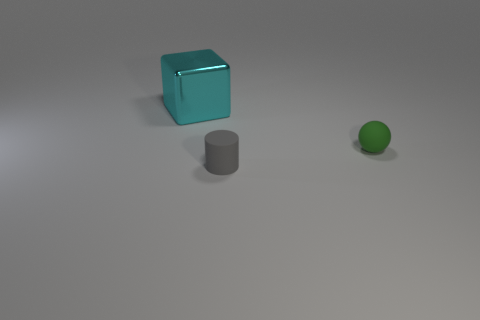Is there any other thing that has the same size as the metallic cube?
Offer a terse response. No. Is the number of blocks right of the tiny cylinder the same as the number of cylinders to the right of the matte ball?
Make the answer very short. Yes. How many metallic objects are large green balls or large cyan blocks?
Provide a short and direct response. 1. There is a tiny gray thing; how many objects are right of it?
Give a very brief answer. 1. Is there another tiny cyan object that has the same material as the cyan object?
Provide a succinct answer. No. Is the tiny green object made of the same material as the cylinder?
Your answer should be very brief. Yes. What number of things are either large cyan balls or rubber objects?
Your answer should be very brief. 2. What shape is the tiny rubber object that is in front of the green object?
Provide a short and direct response. Cylinder. The ball that is the same material as the tiny gray cylinder is what color?
Your answer should be compact. Green. What is the shape of the green rubber thing?
Provide a succinct answer. Sphere. 